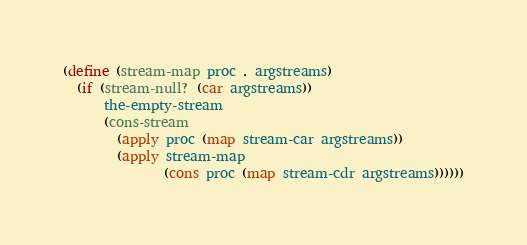Convert code to text. <code><loc_0><loc_0><loc_500><loc_500><_Scheme_>(define (stream-map proc . argstreams)
  (if (stream-null? (car argstreams))
      the-empty-stream
      (cons-stream 
        (apply proc (map stream-car argstreams)) 
        (apply stream-map 
               (cons proc (map stream-cdr argstreams))))))
</code> 